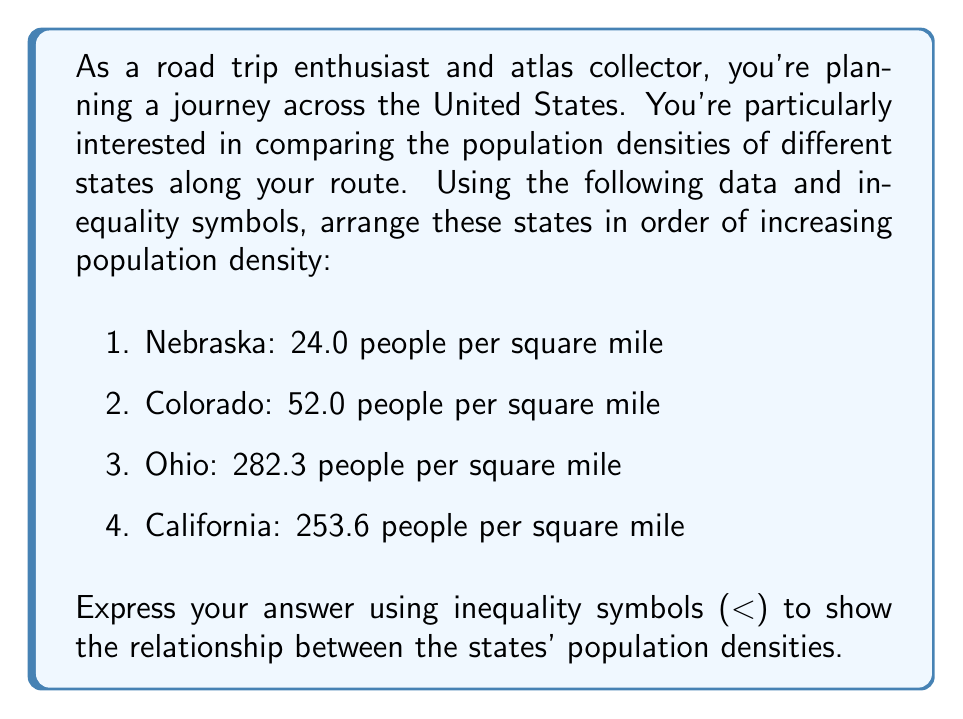Give your solution to this math problem. To solve this problem, we need to arrange the states in order of increasing population density. Let's follow these steps:

1. List out the population densities:
   Nebraska: 24.0 people/sq mi
   Colorado: 52.0 people/sq mi
   Ohio: 282.3 people/sq mi
   California: 253.6 people/sq mi

2. Compare the densities:
   - Nebraska has the lowest density at 24.0 people/sq mi
   - Colorado is next with 52.0 people/sq mi
   - California is third with 253.6 people/sq mi
   - Ohio has the highest density at 282.3 people/sq mi

3. Arrange the states using inequality symbols:

   Let's use abbreviations for the states:
   NE = Nebraska
   CO = Colorado
   CA = California
   OH = Ohio

   The correct arrangement in order of increasing population density is:

   $NE < CO < CA < OH$

This arrangement shows that Nebraska has the lowest population density, followed by Colorado, then California, and finally Ohio with the highest population density among these four states.
Answer: $NE < CO < CA < OH$ 